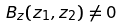Convert formula to latex. <formula><loc_0><loc_0><loc_500><loc_500>B _ { z } ( z _ { 1 } , z _ { 2 } ) \ne 0</formula> 